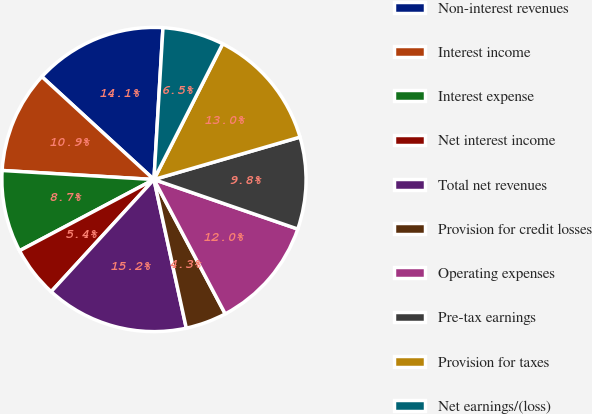<chart> <loc_0><loc_0><loc_500><loc_500><pie_chart><fcel>Non-interest revenues<fcel>Interest income<fcel>Interest expense<fcel>Net interest income<fcel>Total net revenues<fcel>Provision for credit losses<fcel>Operating expenses<fcel>Pre-tax earnings<fcel>Provision for taxes<fcel>Net earnings/(loss)<nl><fcel>14.13%<fcel>10.87%<fcel>8.7%<fcel>5.44%<fcel>15.22%<fcel>4.35%<fcel>11.96%<fcel>9.78%<fcel>13.04%<fcel>6.52%<nl></chart> 